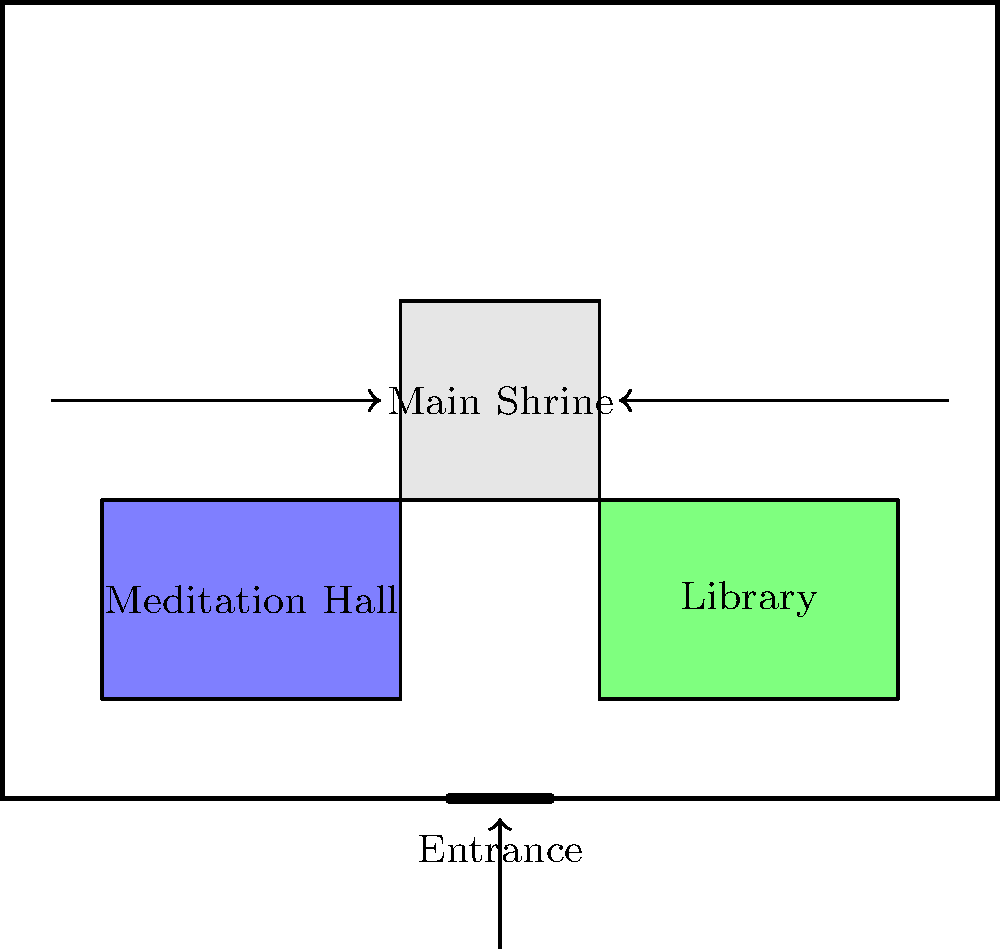In the layout of this Buddhist temple, which area is typically considered the most sacred and centrally located? To answer this question, let's analyze the layout of the Buddhist temple:

1. The diagram shows a rectangular structure representing the temple.
2. There are three main areas within the temple:
   a) A central area labeled "Main Shrine"
   b) An area to the left labeled "Meditation Hall"
   c) An area to the right labeled "Library"
3. The "Main Shrine" is:
   - Located in the center of the temple
   - Slightly larger than the other areas
   - Positioned at the back of the temple, opposite the entrance
4. In Buddhist temple architecture:
   - The main shrine or sanctuary is typically the most sacred area
   - It usually houses the principal Buddha statue or other important relics
   - Its central location symbolizes its importance in Buddhist practice
5. The meditation hall and library, while important, are auxiliary spaces that support spiritual practice and learning.

Given these observations and understanding of Buddhist temple layout, the most sacred and centrally located area is the Main Shrine.
Answer: Main Shrine 